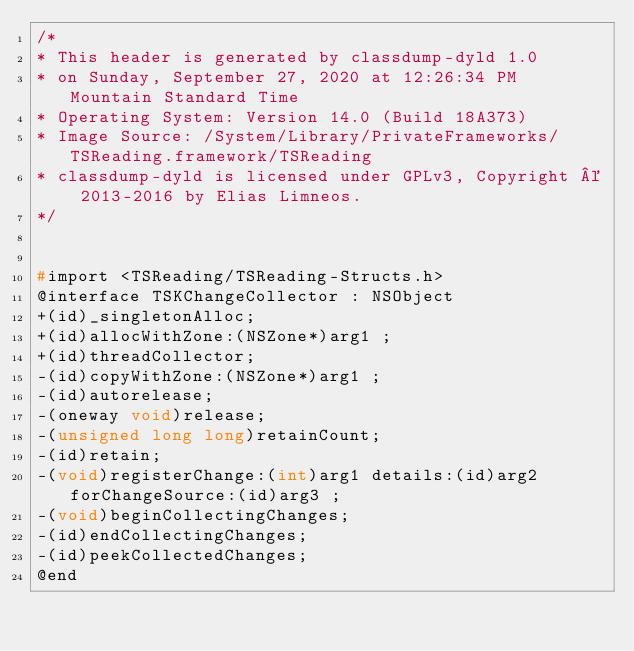<code> <loc_0><loc_0><loc_500><loc_500><_C_>/*
* This header is generated by classdump-dyld 1.0
* on Sunday, September 27, 2020 at 12:26:34 PM Mountain Standard Time
* Operating System: Version 14.0 (Build 18A373)
* Image Source: /System/Library/PrivateFrameworks/TSReading.framework/TSReading
* classdump-dyld is licensed under GPLv3, Copyright © 2013-2016 by Elias Limneos.
*/


#import <TSReading/TSReading-Structs.h>
@interface TSKChangeCollector : NSObject
+(id)_singletonAlloc;
+(id)allocWithZone:(NSZone*)arg1 ;
+(id)threadCollector;
-(id)copyWithZone:(NSZone*)arg1 ;
-(id)autorelease;
-(oneway void)release;
-(unsigned long long)retainCount;
-(id)retain;
-(void)registerChange:(int)arg1 details:(id)arg2 forChangeSource:(id)arg3 ;
-(void)beginCollectingChanges;
-(id)endCollectingChanges;
-(id)peekCollectedChanges;
@end

</code> 